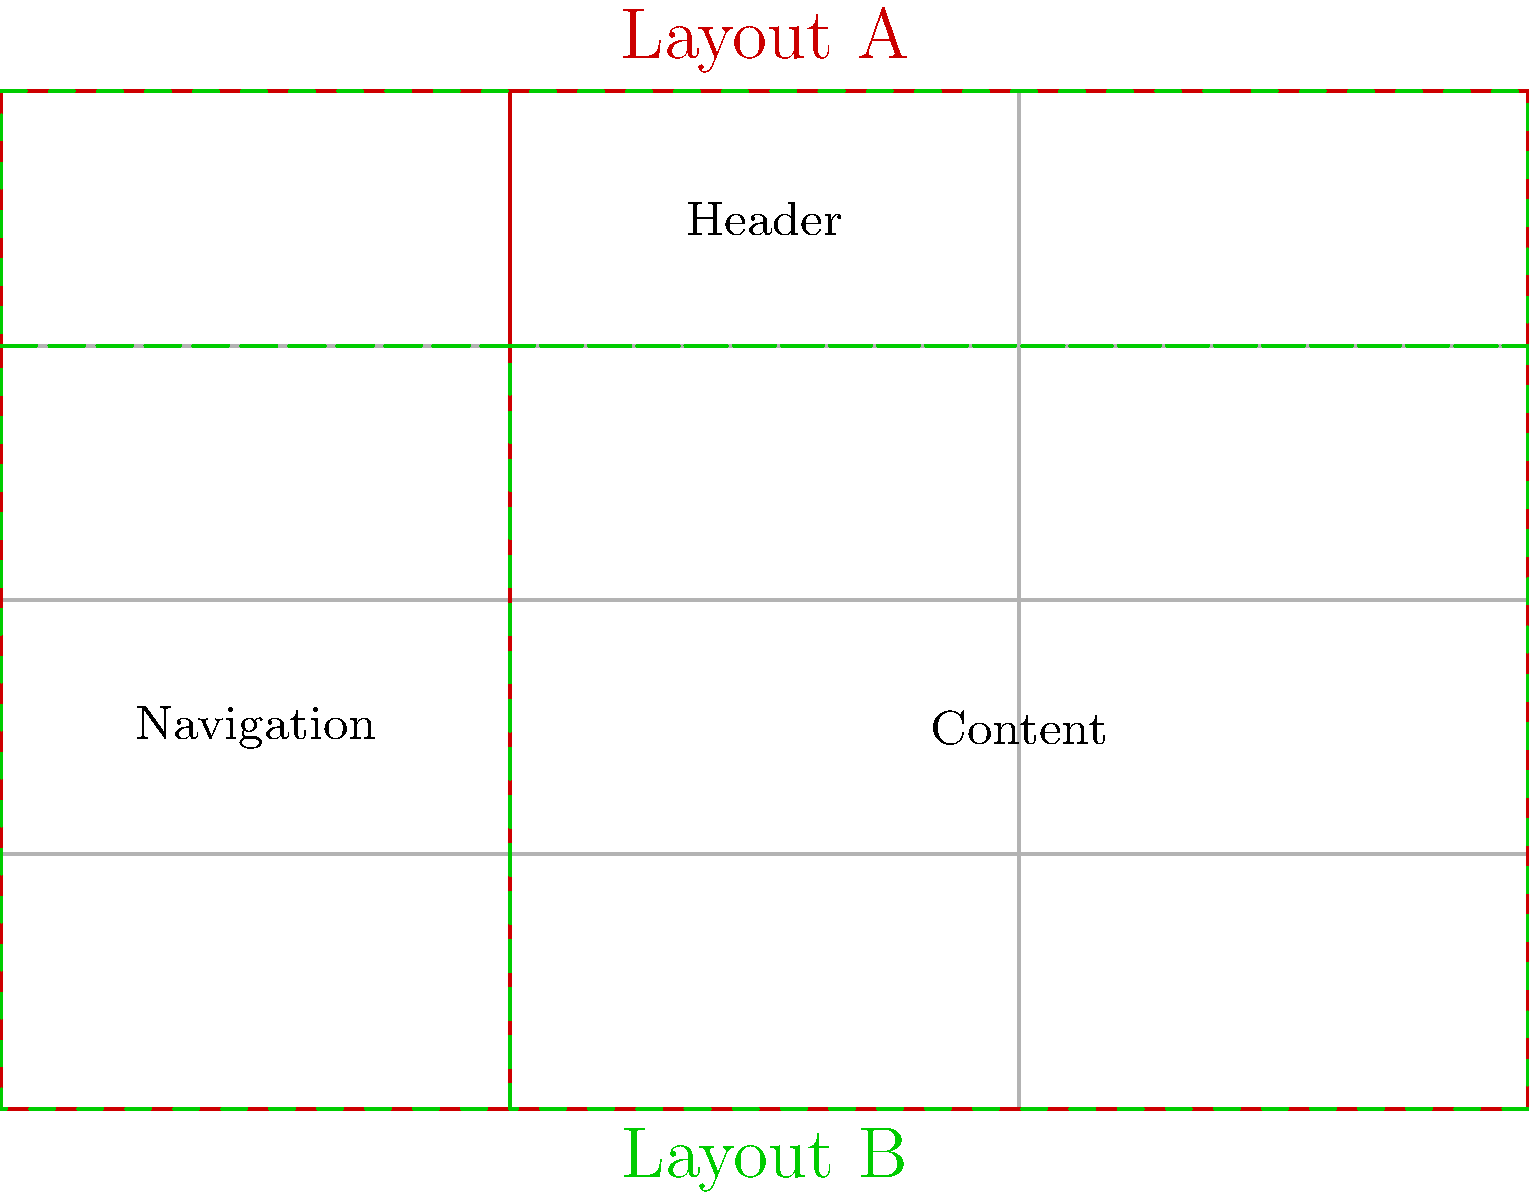Compare the two e-commerce platform layouts (A and B) shown in the wireframe diagram. Which layout is more suitable for a mobile-first design approach, and why? To determine which layout is more suitable for a mobile-first design approach, we need to analyze both layouts considering mobile design principles:

1. Layout A:
   - Header spans the full width
   - Navigation menu is on the left side
   - Content area is on the right side
   - Vertical split between navigation and content

2. Layout B:
   - Header spans the full width
   - Navigation menu is below the header
   - Content area is below the navigation
   - Stacked vertical arrangement

3. Mobile-first design principles:
   - Prioritize content
   - Use a single column layout
   - Stack elements vertically
   - Minimize horizontal scrolling

4. Analysis:
   - Layout A requires horizontal scrolling on mobile devices
   - Layout B follows a stacked, single-column approach
   - Layout B's arrangement is more adaptable to different screen sizes

5. Conclusion:
   Layout B is more suitable for a mobile-first design approach because it:
   - Uses a stacked layout that easily adapts to narrow screens
   - Minimizes the need for horizontal scrolling
   - Follows the natural flow of mobile user interaction (top to bottom)
Answer: Layout B 